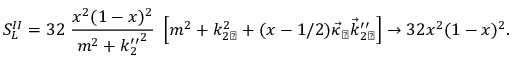Convert formula to latex. <formula><loc_0><loc_0><loc_500><loc_500>S _ { L } ^ { I I } = 3 2 \, \frac { x ^ { 2 } ( 1 - x ) ^ { 2 } } { m ^ { 2 } + { k _ { 2 } ^ { \prime \prime } } ^ { 2 } } \, \left [ m ^ { 2 } + k _ { 2 \perp } ^ { 2 } + ( x - 1 / 2 ) \vec { \kappa } _ { \perp } \vec { k } _ { 2 \perp } ^ { \prime \prime } \right ] \to 3 2 x ^ { 2 } ( 1 - x ) ^ { 2 } .</formula> 